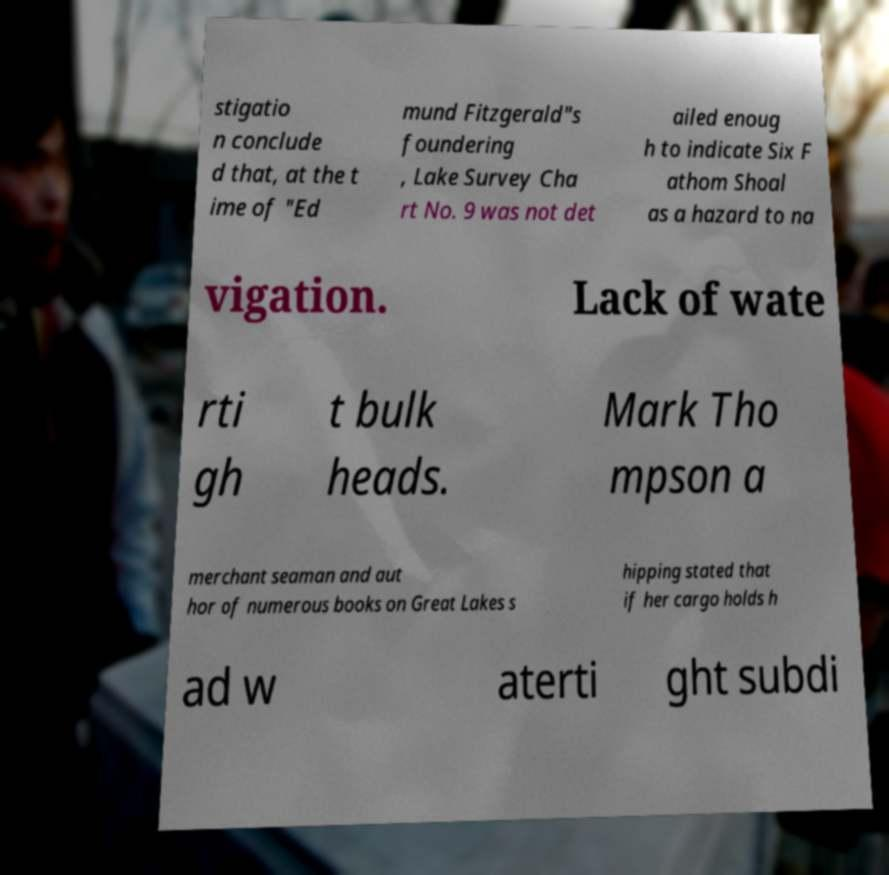Please identify and transcribe the text found in this image. stigatio n conclude d that, at the t ime of "Ed mund Fitzgerald"s foundering , Lake Survey Cha rt No. 9 was not det ailed enoug h to indicate Six F athom Shoal as a hazard to na vigation. Lack of wate rti gh t bulk heads. Mark Tho mpson a merchant seaman and aut hor of numerous books on Great Lakes s hipping stated that if her cargo holds h ad w aterti ght subdi 